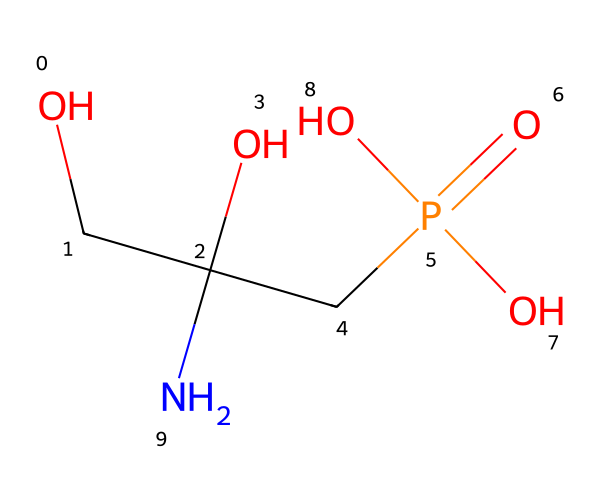What is the molecular formula of glyphosate? To determine the molecular formula from the SMILES notation (OCC(O)(CP(=O)(O)O)N), we need to identify the constituent atoms. Counting the atoms yields: Carbon (C) = 3, Hydrogen (H) = 8, Oxygen (O) = 5, and Nitrogen (N) = 1. Therefore, the molecular formula is C3H8N1O5.
Answer: C3H8NO5 How many carbon atoms are present in the structure? Analyzing the SMILES notation, we can identify and count the carbon atoms indicated by "C" in the structure. There are three occurrences, which represents three carbon atoms in total.
Answer: 3 What type of functional groups are present in glyphosate? By examining the SMILES structure, we see several functional groups: hydroxyl (–OH) groups indicated by (O), a phosphate group indicated by (P(=O)(O)O), and an amine group (–NH) represented by (N). These functional groups indicate glyphosate's chemical properties.
Answer: hydroxyl, phosphate, amine Which atom serves as the central atom in the phosphate group? In the given SMILES representation (CP(=O)(O)O), the phosphorus atom (P) is the central atom of the phosphate group, as it is bonded to both oxygen atoms and is essential for the chemical makeup of the phosphoryl part of glyphosate.
Answer: phosphorus What is the role of the nitrogen atom in glyphosate? In the structure, the nitrogen atom (N) is part of an amine group (–NH) which typically contributes to the herbicidal activity by influencing the overall charge and solubility of glyphosate in biological systems, thus facilitating its interaction with plants.
Answer: herbicidal activity What does the presence of the phosphate group indicate about the herbicidal action of glyphosate? The phosphate group in glyphosate suggests that it may inhibit the shikimic acid pathway, which is crucial for the biosynthesis of aromatic amino acids in plants and some microorganisms. This mechanism underlies glyphosate's effectiveness as a broad-spectrum herbicide.
Answer: inhibits shikimic acid pathway 